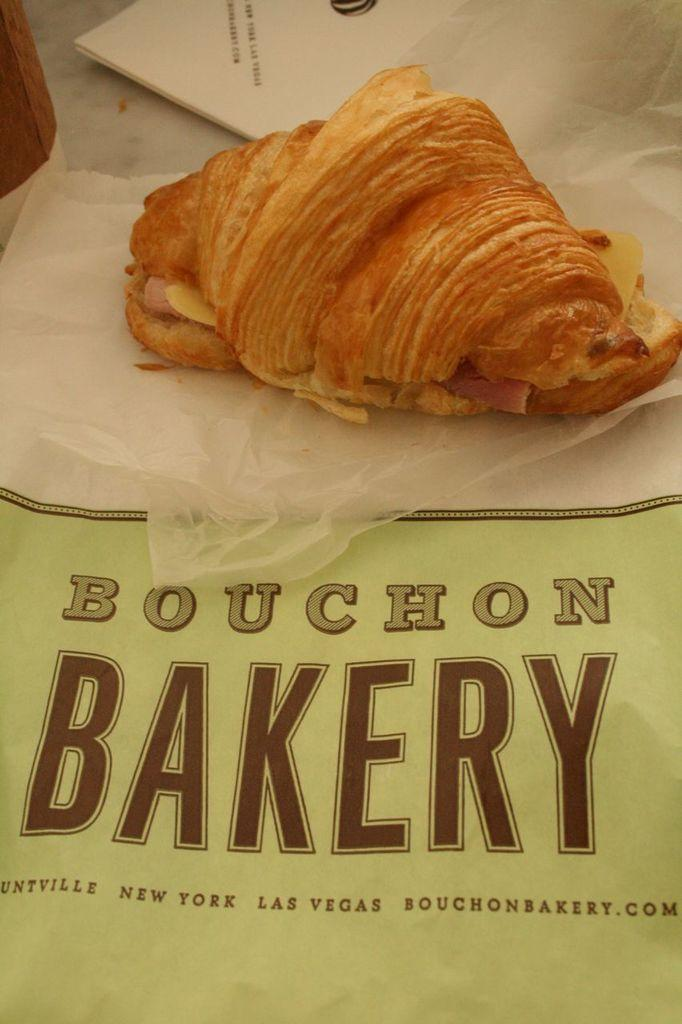What can be seen in the image related to food? There is a food item in the image. What else is present in the image besides the food item? There is text on a paper and tissue papers visible at the top of the image. How many bikes are visible in the image? There are no bikes present in the image. What type of locket is hanging from the food item in the image? There is no locket present in the image. 